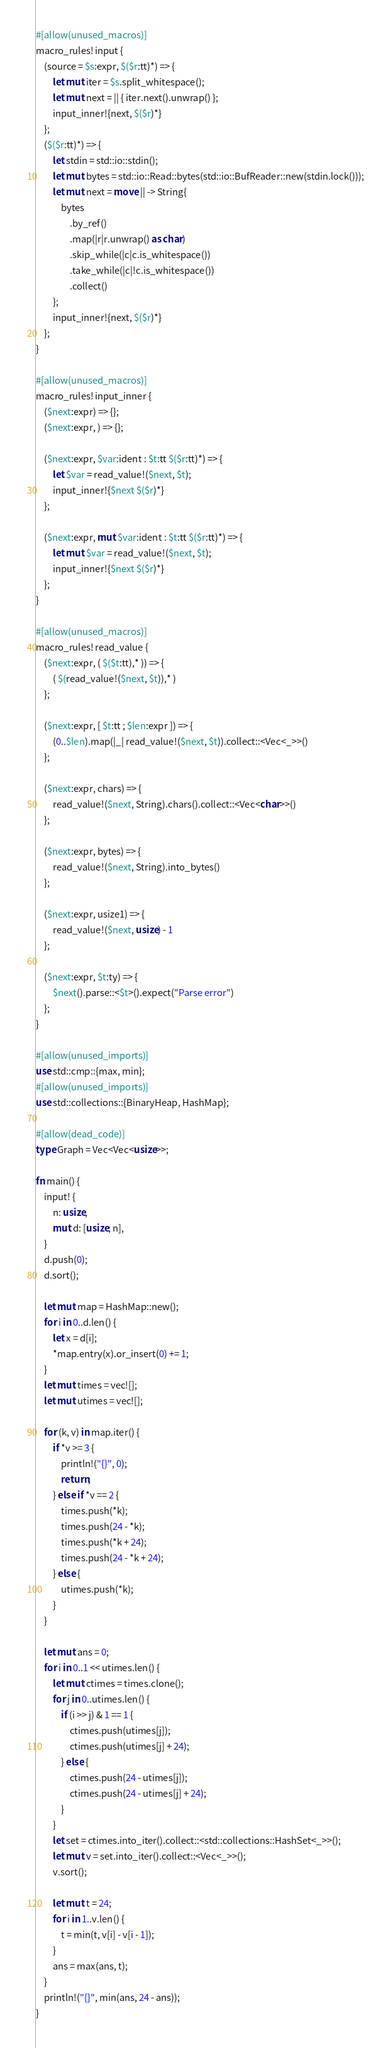Convert code to text. <code><loc_0><loc_0><loc_500><loc_500><_Rust_>#[allow(unused_macros)]
macro_rules! input {
    (source = $s:expr, $($r:tt)*) => {
        let mut iter = $s.split_whitespace();
        let mut next = || { iter.next().unwrap() };
        input_inner!{next, $($r)*}
    };
    ($($r:tt)*) => {
        let stdin = std::io::stdin();
        let mut bytes = std::io::Read::bytes(std::io::BufReader::new(stdin.lock()));
        let mut next = move || -> String{
            bytes
                .by_ref()
                .map(|r|r.unwrap() as char)
                .skip_while(|c|c.is_whitespace())
                .take_while(|c|!c.is_whitespace())
                .collect()
        };
        input_inner!{next, $($r)*}
    };
}

#[allow(unused_macros)]
macro_rules! input_inner {
    ($next:expr) => {};
    ($next:expr, ) => {};

    ($next:expr, $var:ident : $t:tt $($r:tt)*) => {
        let $var = read_value!($next, $t);
        input_inner!{$next $($r)*}
    };

    ($next:expr, mut $var:ident : $t:tt $($r:tt)*) => {
        let mut $var = read_value!($next, $t);
        input_inner!{$next $($r)*}
    };
}

#[allow(unused_macros)]
macro_rules! read_value {
    ($next:expr, ( $($t:tt),* )) => {
        ( $(read_value!($next, $t)),* )
    };

    ($next:expr, [ $t:tt ; $len:expr ]) => {
        (0..$len).map(|_| read_value!($next, $t)).collect::<Vec<_>>()
    };

    ($next:expr, chars) => {
        read_value!($next, String).chars().collect::<Vec<char>>()
    };

    ($next:expr, bytes) => {
        read_value!($next, String).into_bytes()
    };

    ($next:expr, usize1) => {
        read_value!($next, usize) - 1
    };

    ($next:expr, $t:ty) => {
        $next().parse::<$t>().expect("Parse error")
    };
}

#[allow(unused_imports)]
use std::cmp::{max, min};
#[allow(unused_imports)]
use std::collections::{BinaryHeap, HashMap};

#[allow(dead_code)]
type Graph = Vec<Vec<usize>>;

fn main() {
    input! {
        n: usize,
        mut d: [usize; n],
    }
    d.push(0);
    d.sort();

    let mut map = HashMap::new();
    for i in 0..d.len() {
        let x = d[i];
        *map.entry(x).or_insert(0) += 1;
    }
    let mut times = vec![];
    let mut utimes = vec![];

    for (k, v) in map.iter() {
        if *v >= 3 {
            println!("{}", 0);
            return;
        } else if *v == 2 {
            times.push(*k);
            times.push(24 - *k);
            times.push(*k + 24);
            times.push(24 - *k + 24);
        } else {
            utimes.push(*k);
        }
    }

    let mut ans = 0;
    for i in 0..1 << utimes.len() {
        let mut ctimes = times.clone();
        for j in 0..utimes.len() {
            if (i >> j) & 1 == 1 {
                ctimes.push(utimes[j]);
                ctimes.push(utimes[j] + 24);
            } else {
                ctimes.push(24 - utimes[j]);
                ctimes.push(24 - utimes[j] + 24);
            }
        }
        let set = ctimes.into_iter().collect::<std::collections::HashSet<_>>();
        let mut v = set.into_iter().collect::<Vec<_>>();
        v.sort();

        let mut t = 24;
        for i in 1..v.len() {
            t = min(t, v[i] - v[i - 1]);
        }
        ans = max(ans, t);
    }
    println!("{}", min(ans, 24 - ans));
}
</code> 